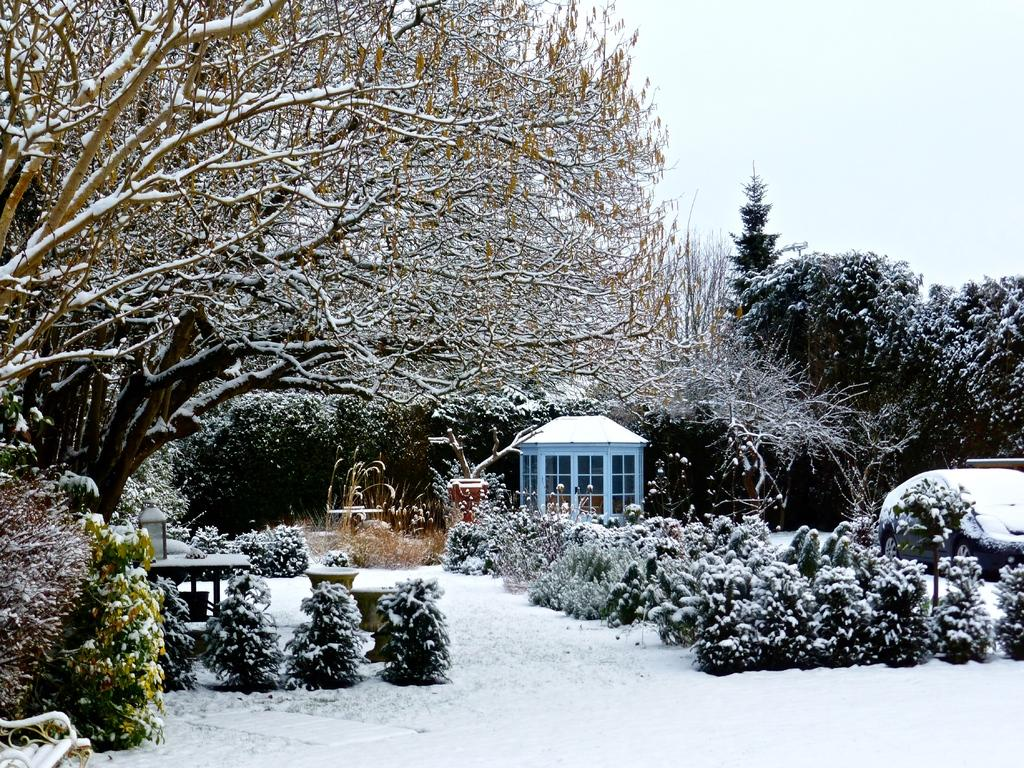What type of natural elements can be seen in the image? There are plants and trees in the image. What weather condition is depicted in the image? There is snow in the image. What type of structure is present in the image? There is a house in the image. What mode of transportation is visible in the image? There is a vehicle in the image. What else can be seen in the image besides the mentioned elements? There are other objects in the image. What is visible in the background of the image? The sky is visible in the background of the image. What type of brake system is installed on the trees in the image? There is no brake system present on the trees in the image; they are natural elements. What type of beam is supporting the sky in the image? The sky in the image is not supported by any beam; it is a natural phenomenon. 